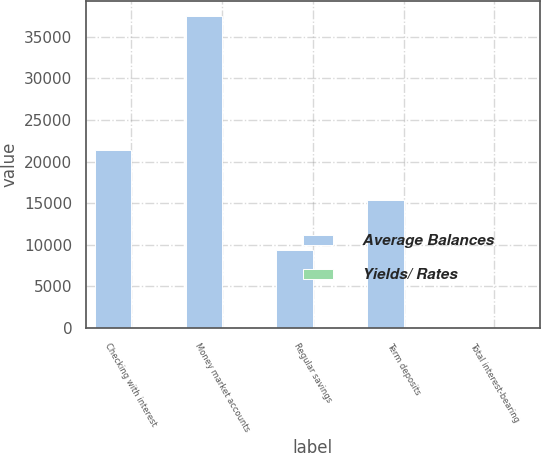Convert chart. <chart><loc_0><loc_0><loc_500><loc_500><stacked_bar_chart><ecel><fcel>Checking with interest<fcel>Money market accounts<fcel>Regular savings<fcel>Term deposits<fcel>Total interest-bearing<nl><fcel>Average Balances<fcel>21458<fcel>37450<fcel>9384<fcel>15448<fcel>1.04<nl><fcel>Yields/ Rates<fcel>0.37<fcel>0.53<fcel>0.04<fcel>1.04<fcel>0.53<nl></chart> 